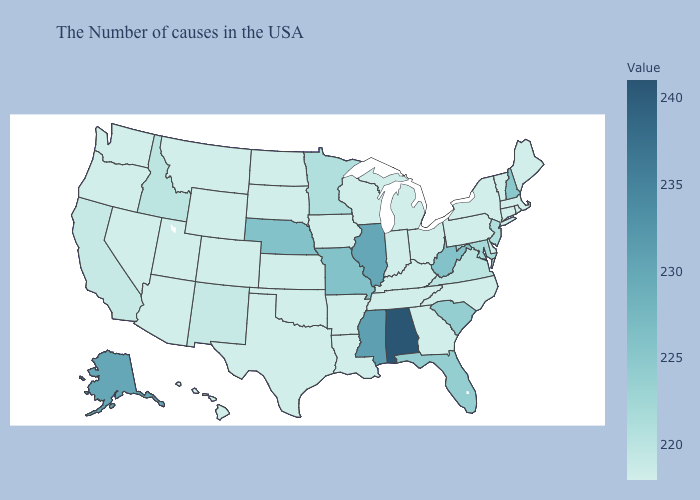Does Oregon have the highest value in the West?
Write a very short answer. No. Does Alabama have a lower value than Arkansas?
Be succinct. No. Which states have the lowest value in the Northeast?
Keep it brief. Maine, Massachusetts, Rhode Island, Vermont, Connecticut, New York, Pennsylvania. Among the states that border Nevada , does Idaho have the highest value?
Keep it brief. Yes. Does the map have missing data?
Write a very short answer. No. 